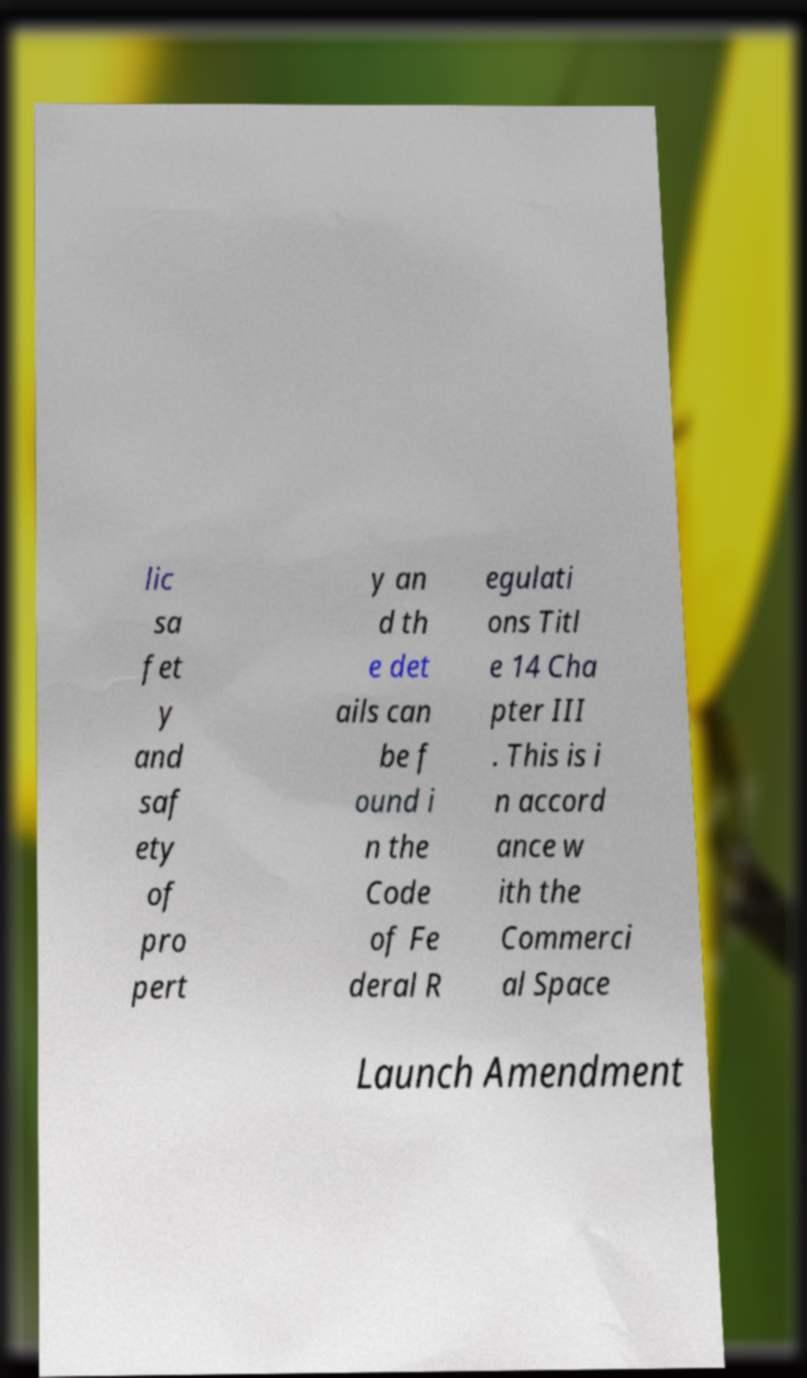Can you read and provide the text displayed in the image?This photo seems to have some interesting text. Can you extract and type it out for me? lic sa fet y and saf ety of pro pert y an d th e det ails can be f ound i n the Code of Fe deral R egulati ons Titl e 14 Cha pter III . This is i n accord ance w ith the Commerci al Space Launch Amendment 